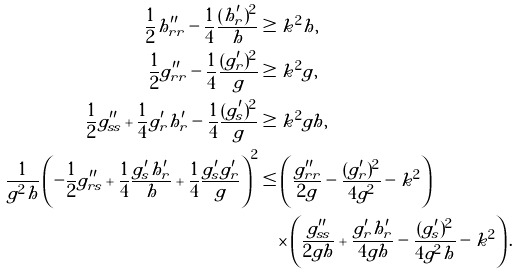Convert formula to latex. <formula><loc_0><loc_0><loc_500><loc_500>\frac { 1 } { 2 } h ^ { \prime \prime } _ { r r } - \frac { 1 } { 4 } \frac { ( h ^ { \prime } _ { r } ) ^ { 2 } } { h } & \geq k ^ { 2 } h , \\ \, \frac { 1 } { 2 } g ^ { \prime \prime } _ { r r } - \frac { 1 } { 4 } \frac { ( g ^ { \prime } _ { r } ) ^ { 2 } } { g } & \geq k ^ { 2 } g , \\ \frac { 1 } { 2 } g ^ { \prime \prime } _ { s s } + \frac { 1 } { 4 } g ^ { \prime } _ { r } h ^ { \prime } _ { r } - \frac { 1 } { 4 } \frac { ( g ^ { \prime } _ { s } ) ^ { 2 } } { g } & \geq k ^ { 2 } g h , \\ \frac { 1 } { g ^ { 2 } h } \left ( - \frac { 1 } { 2 } g ^ { \prime \prime } _ { r s } + \frac { 1 } { 4 } \frac { g ^ { \prime } _ { s } h ^ { \prime } _ { r } } { h } + \frac { 1 } { 4 } \frac { g ^ { \prime } _ { s } g ^ { \prime } _ { r } } { g } \right ) ^ { 2 } & \leq \left ( \frac { g ^ { \prime \prime } _ { r r } } { 2 g } - \frac { ( g ^ { \prime } _ { r } ) ^ { 2 } } { 4 g ^ { 2 } } - k ^ { 2 } \right ) \\ & \quad \times \left ( \frac { g ^ { \prime \prime } _ { s s } } { 2 g h } + \frac { g ^ { \prime } _ { r } h ^ { \prime } _ { r } } { 4 g h } - \frac { ( g ^ { \prime } _ { s } ) ^ { 2 } } { 4 g ^ { 2 } h } - k ^ { 2 } \right ) .</formula> 